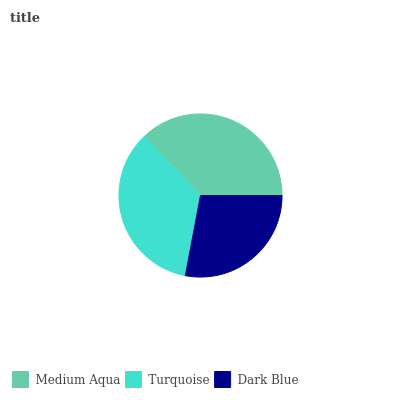Is Dark Blue the minimum?
Answer yes or no. Yes. Is Medium Aqua the maximum?
Answer yes or no. Yes. Is Turquoise the minimum?
Answer yes or no. No. Is Turquoise the maximum?
Answer yes or no. No. Is Medium Aqua greater than Turquoise?
Answer yes or no. Yes. Is Turquoise less than Medium Aqua?
Answer yes or no. Yes. Is Turquoise greater than Medium Aqua?
Answer yes or no. No. Is Medium Aqua less than Turquoise?
Answer yes or no. No. Is Turquoise the high median?
Answer yes or no. Yes. Is Turquoise the low median?
Answer yes or no. Yes. Is Medium Aqua the high median?
Answer yes or no. No. Is Medium Aqua the low median?
Answer yes or no. No. 